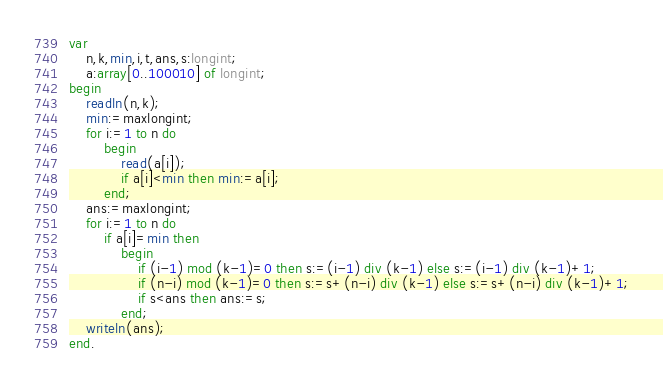<code> <loc_0><loc_0><loc_500><loc_500><_Pascal_>var
    n,k,min,i,t,ans,s:longint;
    a:array[0..100010] of longint;
begin
    readln(n,k);
    min:=maxlongint;
    for i:=1 to n do
        begin
            read(a[i]);
            if a[i]<min then min:=a[i];
        end;
    ans:=maxlongint;
    for i:=1 to n do
        if a[i]=min then
            begin 
                if (i-1) mod (k-1)=0 then s:=(i-1) div (k-1) else s:=(i-1) div (k-1)+1;
                if (n-i) mod (k-1)=0 then s:=s+(n-i) div (k-1) else s:=s+(n-i) div (k-1)+1;
                if s<ans then ans:=s;
            end;
    writeln(ans);
end.</code> 